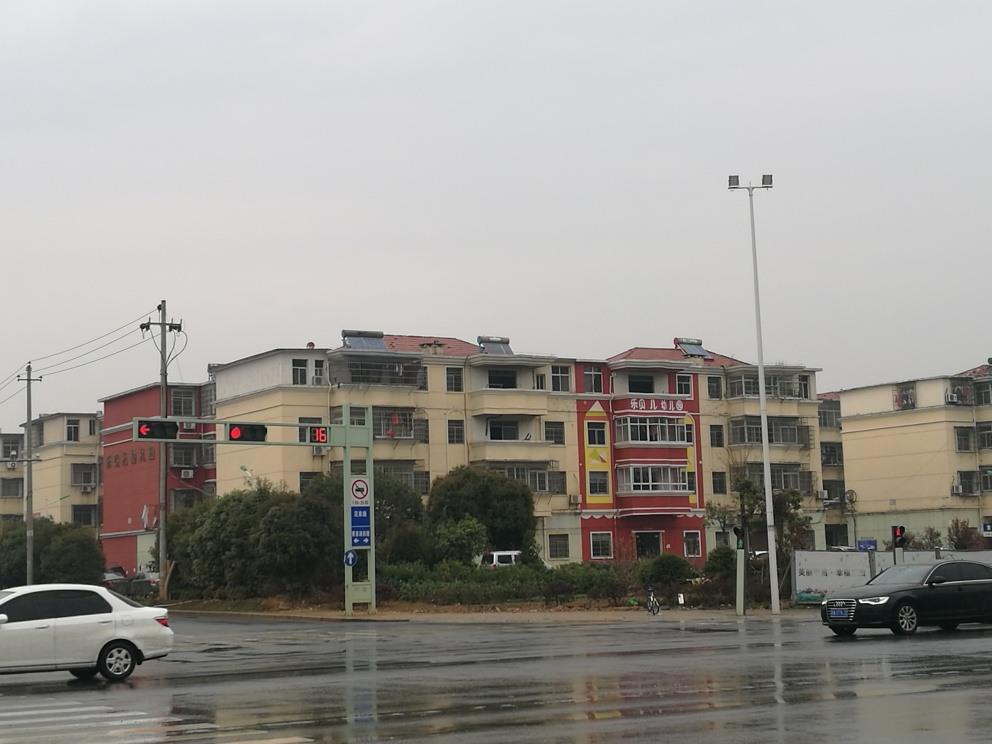How clear is the background of the image? A. Obscured B. Relatively clear C. Blurry D. Indistinct Answer with the option's letter from the given choices directly. The background of the image consists primarily of buildings that, while not in sharp focus, are reasonably discernible with identifiable architectural features, colors, and windows. The weather appears to be overcast, lending a slight haze to the image, but details such as the presence of cars, street signs and the general urban infrastructure are perceptible. Overall, the background is relatively clear with moderate clarity. Therefore, the most accurate description from the provided choices would be option B, 'Relatively clear.' 